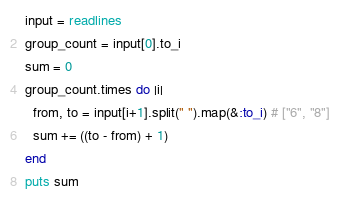Convert code to text. <code><loc_0><loc_0><loc_500><loc_500><_Ruby_>input = readlines
group_count = input[0].to_i
sum = 0
group_count.times do |i|
  from, to = input[i+1].split(" ").map(&:to_i) # ["6", "8"]
  sum += ((to - from) + 1)
end
puts sum</code> 